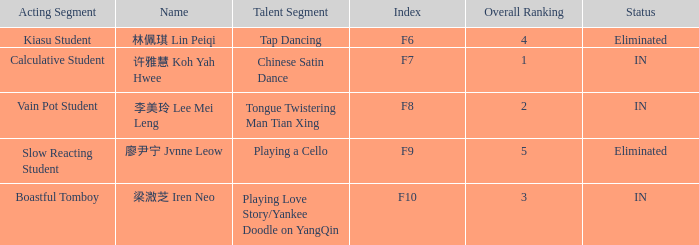What's the total number of overall rankings of 廖尹宁 jvnne leow's events that are eliminated? 1.0. 